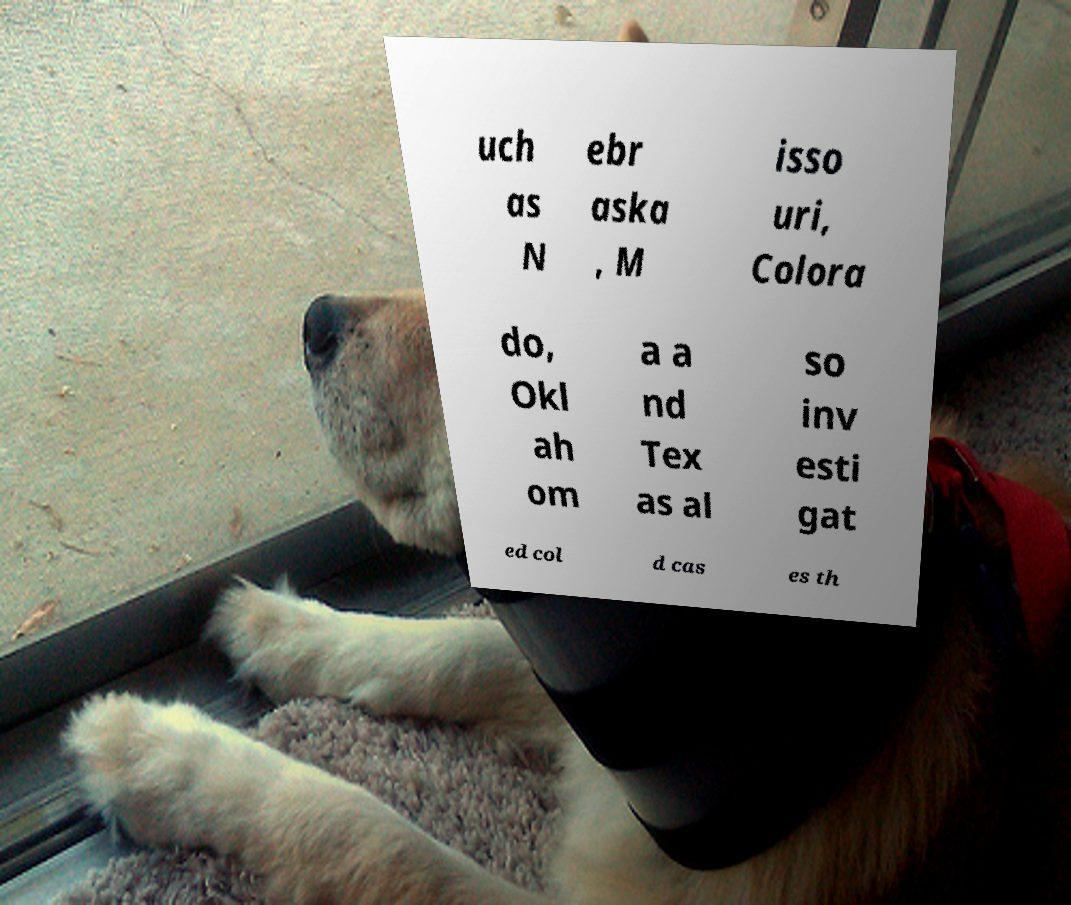I need the written content from this picture converted into text. Can you do that? uch as N ebr aska , M isso uri, Colora do, Okl ah om a a nd Tex as al so inv esti gat ed col d cas es th 